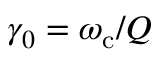<formula> <loc_0><loc_0><loc_500><loc_500>\gamma _ { 0 } = \omega _ { c } / Q</formula> 